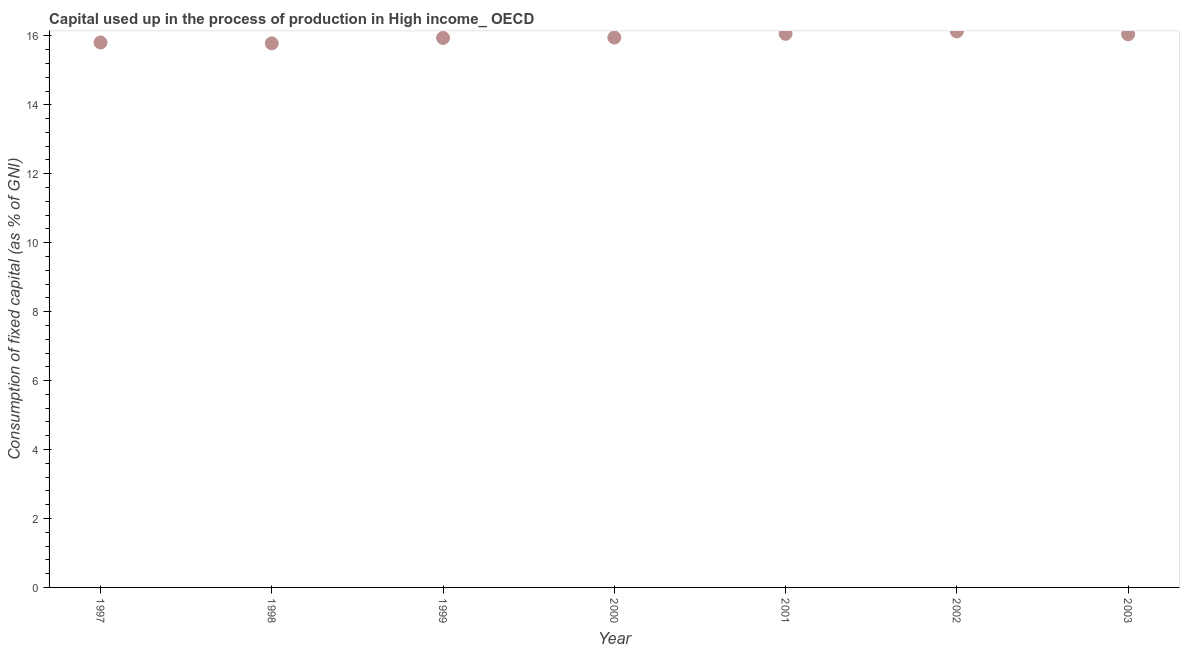What is the consumption of fixed capital in 1999?
Keep it short and to the point. 15.94. Across all years, what is the maximum consumption of fixed capital?
Make the answer very short. 16.13. Across all years, what is the minimum consumption of fixed capital?
Offer a very short reply. 15.78. In which year was the consumption of fixed capital minimum?
Offer a terse response. 1998. What is the sum of the consumption of fixed capital?
Offer a terse response. 111.72. What is the difference between the consumption of fixed capital in 1998 and 2003?
Provide a short and direct response. -0.26. What is the average consumption of fixed capital per year?
Your answer should be very brief. 15.96. What is the median consumption of fixed capital?
Provide a short and direct response. 15.95. What is the ratio of the consumption of fixed capital in 2000 to that in 2002?
Make the answer very short. 0.99. Is the difference between the consumption of fixed capital in 1997 and 1999 greater than the difference between any two years?
Offer a terse response. No. What is the difference between the highest and the second highest consumption of fixed capital?
Your answer should be compact. 0.07. Is the sum of the consumption of fixed capital in 1998 and 2003 greater than the maximum consumption of fixed capital across all years?
Your answer should be very brief. Yes. What is the difference between the highest and the lowest consumption of fixed capital?
Keep it short and to the point. 0.35. In how many years, is the consumption of fixed capital greater than the average consumption of fixed capital taken over all years?
Make the answer very short. 3. How many dotlines are there?
Provide a succinct answer. 1. What is the difference between two consecutive major ticks on the Y-axis?
Offer a terse response. 2. Does the graph contain any zero values?
Ensure brevity in your answer.  No. What is the title of the graph?
Give a very brief answer. Capital used up in the process of production in High income_ OECD. What is the label or title of the Y-axis?
Give a very brief answer. Consumption of fixed capital (as % of GNI). What is the Consumption of fixed capital (as % of GNI) in 1997?
Give a very brief answer. 15.81. What is the Consumption of fixed capital (as % of GNI) in 1998?
Give a very brief answer. 15.78. What is the Consumption of fixed capital (as % of GNI) in 1999?
Offer a very short reply. 15.94. What is the Consumption of fixed capital (as % of GNI) in 2000?
Provide a succinct answer. 15.95. What is the Consumption of fixed capital (as % of GNI) in 2001?
Give a very brief answer. 16.06. What is the Consumption of fixed capital (as % of GNI) in 2002?
Provide a short and direct response. 16.13. What is the Consumption of fixed capital (as % of GNI) in 2003?
Provide a succinct answer. 16.05. What is the difference between the Consumption of fixed capital (as % of GNI) in 1997 and 1998?
Ensure brevity in your answer.  0.03. What is the difference between the Consumption of fixed capital (as % of GNI) in 1997 and 1999?
Provide a succinct answer. -0.13. What is the difference between the Consumption of fixed capital (as % of GNI) in 1997 and 2000?
Keep it short and to the point. -0.14. What is the difference between the Consumption of fixed capital (as % of GNI) in 1997 and 2001?
Provide a succinct answer. -0.25. What is the difference between the Consumption of fixed capital (as % of GNI) in 1997 and 2002?
Your response must be concise. -0.32. What is the difference between the Consumption of fixed capital (as % of GNI) in 1997 and 2003?
Make the answer very short. -0.24. What is the difference between the Consumption of fixed capital (as % of GNI) in 1998 and 1999?
Keep it short and to the point. -0.16. What is the difference between the Consumption of fixed capital (as % of GNI) in 1998 and 2000?
Provide a short and direct response. -0.17. What is the difference between the Consumption of fixed capital (as % of GNI) in 1998 and 2001?
Offer a very short reply. -0.28. What is the difference between the Consumption of fixed capital (as % of GNI) in 1998 and 2002?
Offer a very short reply. -0.35. What is the difference between the Consumption of fixed capital (as % of GNI) in 1998 and 2003?
Offer a terse response. -0.26. What is the difference between the Consumption of fixed capital (as % of GNI) in 1999 and 2000?
Offer a terse response. -0.01. What is the difference between the Consumption of fixed capital (as % of GNI) in 1999 and 2001?
Provide a short and direct response. -0.12. What is the difference between the Consumption of fixed capital (as % of GNI) in 1999 and 2002?
Offer a very short reply. -0.19. What is the difference between the Consumption of fixed capital (as % of GNI) in 1999 and 2003?
Offer a terse response. -0.11. What is the difference between the Consumption of fixed capital (as % of GNI) in 2000 and 2001?
Your answer should be very brief. -0.11. What is the difference between the Consumption of fixed capital (as % of GNI) in 2000 and 2002?
Offer a terse response. -0.18. What is the difference between the Consumption of fixed capital (as % of GNI) in 2000 and 2003?
Your response must be concise. -0.09. What is the difference between the Consumption of fixed capital (as % of GNI) in 2001 and 2002?
Give a very brief answer. -0.07. What is the difference between the Consumption of fixed capital (as % of GNI) in 2001 and 2003?
Your response must be concise. 0.01. What is the difference between the Consumption of fixed capital (as % of GNI) in 2002 and 2003?
Your answer should be compact. 0.08. What is the ratio of the Consumption of fixed capital (as % of GNI) in 1997 to that in 1998?
Provide a succinct answer. 1. What is the ratio of the Consumption of fixed capital (as % of GNI) in 1997 to that in 1999?
Provide a short and direct response. 0.99. What is the ratio of the Consumption of fixed capital (as % of GNI) in 1997 to that in 2000?
Provide a short and direct response. 0.99. What is the ratio of the Consumption of fixed capital (as % of GNI) in 1997 to that in 2002?
Your response must be concise. 0.98. What is the ratio of the Consumption of fixed capital (as % of GNI) in 1998 to that in 2000?
Make the answer very short. 0.99. What is the ratio of the Consumption of fixed capital (as % of GNI) in 1998 to that in 2003?
Keep it short and to the point. 0.98. What is the ratio of the Consumption of fixed capital (as % of GNI) in 1999 to that in 2000?
Offer a terse response. 1. What is the ratio of the Consumption of fixed capital (as % of GNI) in 1999 to that in 2001?
Ensure brevity in your answer.  0.99. What is the ratio of the Consumption of fixed capital (as % of GNI) in 1999 to that in 2002?
Give a very brief answer. 0.99. What is the ratio of the Consumption of fixed capital (as % of GNI) in 1999 to that in 2003?
Your answer should be very brief. 0.99. What is the ratio of the Consumption of fixed capital (as % of GNI) in 2000 to that in 2001?
Provide a short and direct response. 0.99. What is the ratio of the Consumption of fixed capital (as % of GNI) in 2000 to that in 2003?
Provide a succinct answer. 0.99. What is the ratio of the Consumption of fixed capital (as % of GNI) in 2001 to that in 2002?
Offer a terse response. 1. What is the ratio of the Consumption of fixed capital (as % of GNI) in 2001 to that in 2003?
Offer a very short reply. 1. What is the ratio of the Consumption of fixed capital (as % of GNI) in 2002 to that in 2003?
Make the answer very short. 1. 